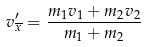Convert formula to latex. <formula><loc_0><loc_0><loc_500><loc_500>v _ { \overline { x } } ^ { \prime } = \frac { m _ { 1 } v _ { 1 } + m _ { 2 } v _ { 2 } } { m _ { 1 } + m _ { 2 } }</formula> 